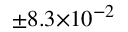<formula> <loc_0><loc_0><loc_500><loc_500>^ { \pm 8 . 3 \times 1 0 ^ { - 2 } }</formula> 